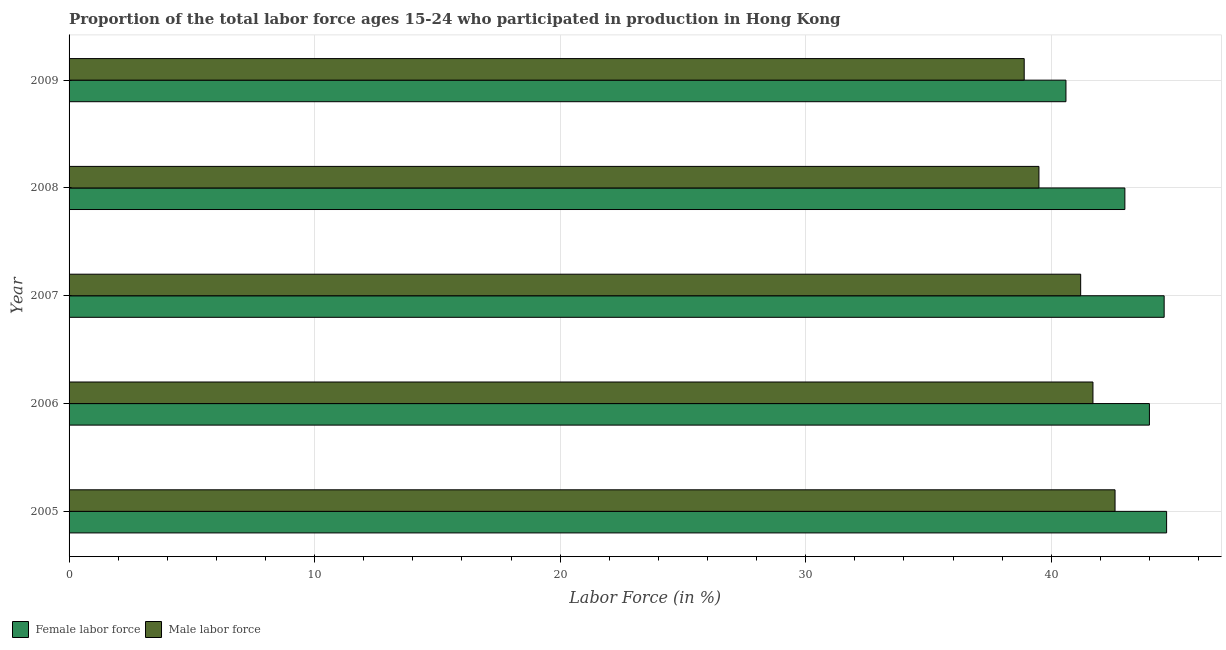How many different coloured bars are there?
Provide a succinct answer. 2. Are the number of bars per tick equal to the number of legend labels?
Make the answer very short. Yes. Are the number of bars on each tick of the Y-axis equal?
Provide a short and direct response. Yes. How many bars are there on the 2nd tick from the top?
Provide a succinct answer. 2. What is the percentage of female labor force in 2006?
Your answer should be very brief. 44. Across all years, what is the maximum percentage of male labour force?
Your answer should be compact. 42.6. Across all years, what is the minimum percentage of male labour force?
Your answer should be very brief. 38.9. In which year was the percentage of male labour force minimum?
Your answer should be very brief. 2009. What is the total percentage of female labor force in the graph?
Offer a very short reply. 216.9. What is the difference between the percentage of female labor force in 2006 and that in 2008?
Provide a succinct answer. 1. What is the average percentage of male labour force per year?
Offer a very short reply. 40.78. What is the ratio of the percentage of female labor force in 2005 to that in 2007?
Give a very brief answer. 1. Is the percentage of female labor force in 2005 less than that in 2006?
Give a very brief answer. No. Is the difference between the percentage of male labour force in 2008 and 2009 greater than the difference between the percentage of female labor force in 2008 and 2009?
Give a very brief answer. No. What is the difference between the highest and the lowest percentage of male labour force?
Your answer should be very brief. 3.7. In how many years, is the percentage of male labour force greater than the average percentage of male labour force taken over all years?
Provide a short and direct response. 3. What does the 2nd bar from the top in 2005 represents?
Your response must be concise. Female labor force. What does the 2nd bar from the bottom in 2009 represents?
Offer a terse response. Male labor force. Are all the bars in the graph horizontal?
Your response must be concise. Yes. Does the graph contain any zero values?
Offer a very short reply. No. How many legend labels are there?
Provide a succinct answer. 2. How are the legend labels stacked?
Make the answer very short. Horizontal. What is the title of the graph?
Your answer should be compact. Proportion of the total labor force ages 15-24 who participated in production in Hong Kong. Does "Current US$" appear as one of the legend labels in the graph?
Ensure brevity in your answer.  No. What is the Labor Force (in %) of Female labor force in 2005?
Offer a terse response. 44.7. What is the Labor Force (in %) in Male labor force in 2005?
Your response must be concise. 42.6. What is the Labor Force (in %) in Male labor force in 2006?
Your answer should be very brief. 41.7. What is the Labor Force (in %) in Female labor force in 2007?
Keep it short and to the point. 44.6. What is the Labor Force (in %) in Male labor force in 2007?
Your answer should be compact. 41.2. What is the Labor Force (in %) in Male labor force in 2008?
Offer a very short reply. 39.5. What is the Labor Force (in %) of Female labor force in 2009?
Offer a very short reply. 40.6. What is the Labor Force (in %) in Male labor force in 2009?
Offer a very short reply. 38.9. Across all years, what is the maximum Labor Force (in %) of Female labor force?
Offer a terse response. 44.7. Across all years, what is the maximum Labor Force (in %) of Male labor force?
Your response must be concise. 42.6. Across all years, what is the minimum Labor Force (in %) in Female labor force?
Your response must be concise. 40.6. Across all years, what is the minimum Labor Force (in %) of Male labor force?
Give a very brief answer. 38.9. What is the total Labor Force (in %) in Female labor force in the graph?
Your answer should be compact. 216.9. What is the total Labor Force (in %) of Male labor force in the graph?
Make the answer very short. 203.9. What is the difference between the Labor Force (in %) of Female labor force in 2005 and that in 2006?
Your answer should be very brief. 0.7. What is the difference between the Labor Force (in %) in Male labor force in 2005 and that in 2006?
Offer a terse response. 0.9. What is the difference between the Labor Force (in %) in Female labor force in 2005 and that in 2009?
Offer a terse response. 4.1. What is the difference between the Labor Force (in %) of Male labor force in 2006 and that in 2008?
Offer a terse response. 2.2. What is the difference between the Labor Force (in %) in Female labor force in 2006 and that in 2009?
Your answer should be very brief. 3.4. What is the difference between the Labor Force (in %) of Male labor force in 2006 and that in 2009?
Provide a succinct answer. 2.8. What is the difference between the Labor Force (in %) of Female labor force in 2007 and that in 2008?
Offer a terse response. 1.6. What is the difference between the Labor Force (in %) in Male labor force in 2007 and that in 2009?
Make the answer very short. 2.3. What is the difference between the Labor Force (in %) of Female labor force in 2008 and that in 2009?
Offer a very short reply. 2.4. What is the difference between the Labor Force (in %) in Male labor force in 2008 and that in 2009?
Your answer should be very brief. 0.6. What is the difference between the Labor Force (in %) in Female labor force in 2005 and the Labor Force (in %) in Male labor force in 2007?
Your answer should be very brief. 3.5. What is the difference between the Labor Force (in %) of Female labor force in 2005 and the Labor Force (in %) of Male labor force in 2009?
Give a very brief answer. 5.8. What is the difference between the Labor Force (in %) of Female labor force in 2006 and the Labor Force (in %) of Male labor force in 2008?
Provide a short and direct response. 4.5. What is the difference between the Labor Force (in %) of Female labor force in 2007 and the Labor Force (in %) of Male labor force in 2009?
Provide a succinct answer. 5.7. What is the difference between the Labor Force (in %) of Female labor force in 2008 and the Labor Force (in %) of Male labor force in 2009?
Keep it short and to the point. 4.1. What is the average Labor Force (in %) in Female labor force per year?
Offer a very short reply. 43.38. What is the average Labor Force (in %) in Male labor force per year?
Offer a terse response. 40.78. In the year 2005, what is the difference between the Labor Force (in %) in Female labor force and Labor Force (in %) in Male labor force?
Your answer should be compact. 2.1. In the year 2008, what is the difference between the Labor Force (in %) of Female labor force and Labor Force (in %) of Male labor force?
Make the answer very short. 3.5. What is the ratio of the Labor Force (in %) in Female labor force in 2005 to that in 2006?
Your response must be concise. 1.02. What is the ratio of the Labor Force (in %) in Male labor force in 2005 to that in 2006?
Your answer should be very brief. 1.02. What is the ratio of the Labor Force (in %) of Female labor force in 2005 to that in 2007?
Give a very brief answer. 1. What is the ratio of the Labor Force (in %) in Male labor force in 2005 to that in 2007?
Give a very brief answer. 1.03. What is the ratio of the Labor Force (in %) in Female labor force in 2005 to that in 2008?
Provide a short and direct response. 1.04. What is the ratio of the Labor Force (in %) of Male labor force in 2005 to that in 2008?
Make the answer very short. 1.08. What is the ratio of the Labor Force (in %) of Female labor force in 2005 to that in 2009?
Your response must be concise. 1.1. What is the ratio of the Labor Force (in %) of Male labor force in 2005 to that in 2009?
Give a very brief answer. 1.1. What is the ratio of the Labor Force (in %) of Female labor force in 2006 to that in 2007?
Offer a very short reply. 0.99. What is the ratio of the Labor Force (in %) of Male labor force in 2006 to that in 2007?
Make the answer very short. 1.01. What is the ratio of the Labor Force (in %) in Female labor force in 2006 to that in 2008?
Offer a terse response. 1.02. What is the ratio of the Labor Force (in %) of Male labor force in 2006 to that in 2008?
Keep it short and to the point. 1.06. What is the ratio of the Labor Force (in %) of Female labor force in 2006 to that in 2009?
Provide a succinct answer. 1.08. What is the ratio of the Labor Force (in %) of Male labor force in 2006 to that in 2009?
Make the answer very short. 1.07. What is the ratio of the Labor Force (in %) of Female labor force in 2007 to that in 2008?
Your answer should be very brief. 1.04. What is the ratio of the Labor Force (in %) of Male labor force in 2007 to that in 2008?
Make the answer very short. 1.04. What is the ratio of the Labor Force (in %) in Female labor force in 2007 to that in 2009?
Provide a succinct answer. 1.1. What is the ratio of the Labor Force (in %) of Male labor force in 2007 to that in 2009?
Provide a short and direct response. 1.06. What is the ratio of the Labor Force (in %) in Female labor force in 2008 to that in 2009?
Ensure brevity in your answer.  1.06. What is the ratio of the Labor Force (in %) of Male labor force in 2008 to that in 2009?
Give a very brief answer. 1.02. What is the difference between the highest and the second highest Labor Force (in %) in Female labor force?
Keep it short and to the point. 0.1. What is the difference between the highest and the lowest Labor Force (in %) of Female labor force?
Make the answer very short. 4.1. 